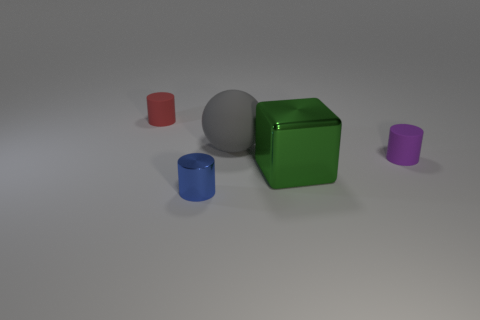Add 3 brown metal cubes. How many objects exist? 8 Subtract all cubes. How many objects are left? 4 Add 1 big cyan metal blocks. How many big cyan metal blocks exist? 1 Subtract 1 green cubes. How many objects are left? 4 Subtract all small red matte cylinders. Subtract all large green cubes. How many objects are left? 3 Add 1 cylinders. How many cylinders are left? 4 